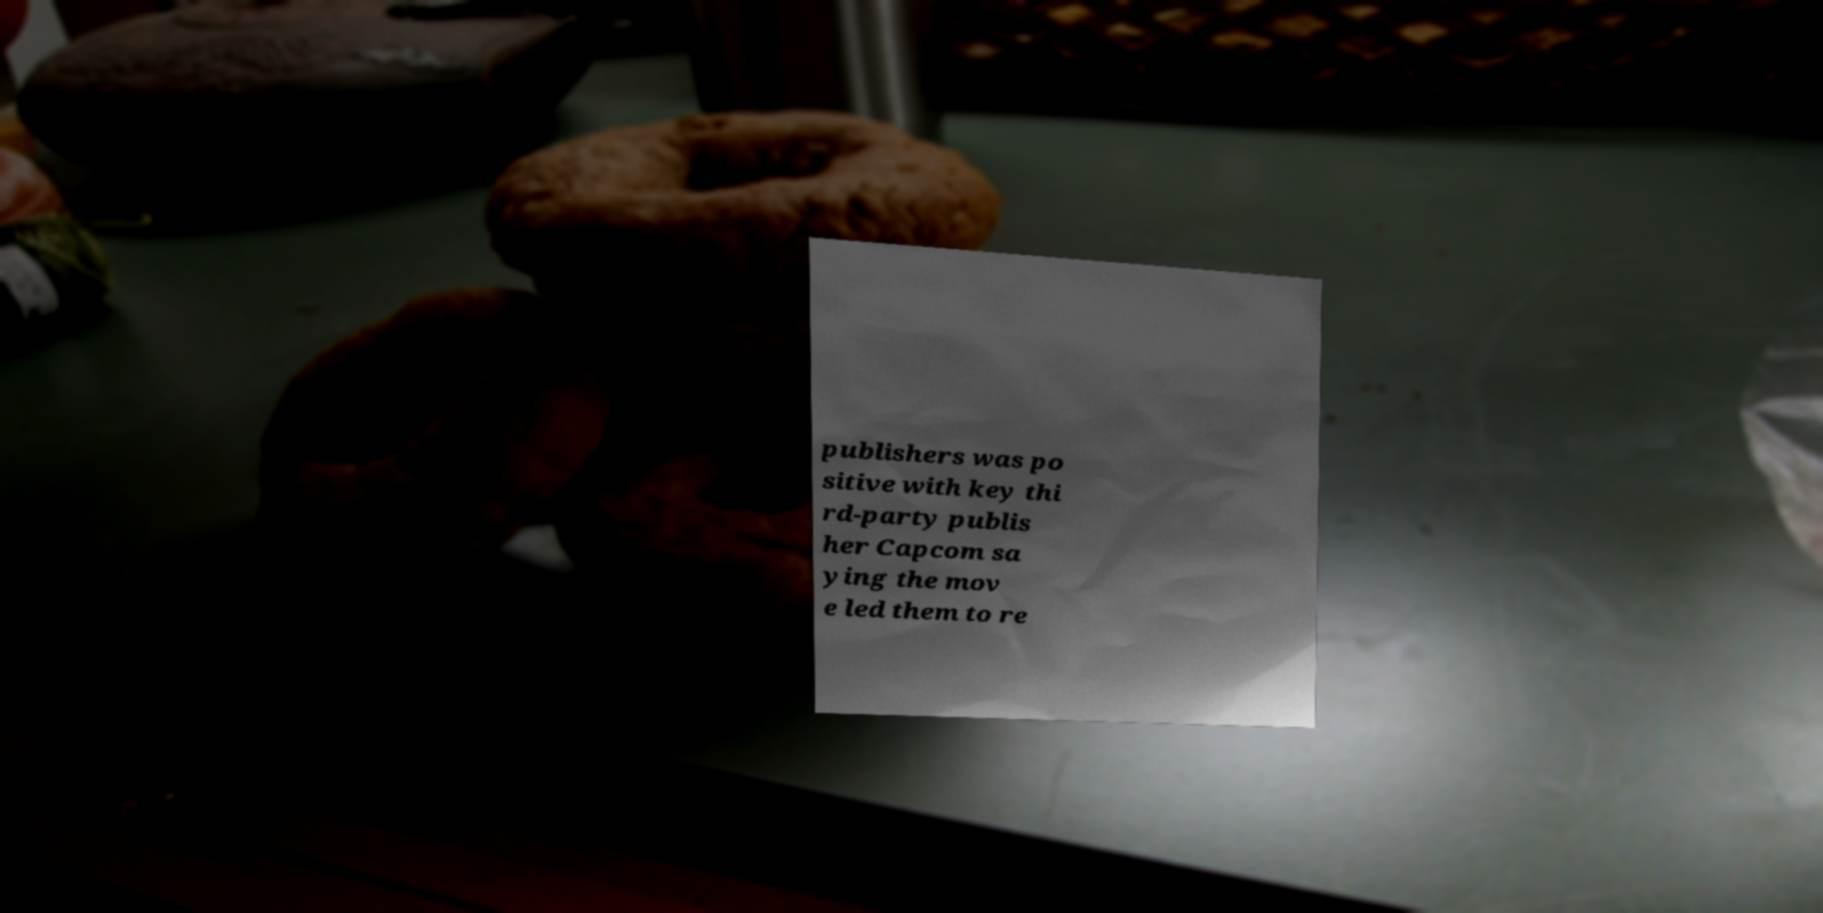Can you read and provide the text displayed in the image?This photo seems to have some interesting text. Can you extract and type it out for me? publishers was po sitive with key thi rd-party publis her Capcom sa ying the mov e led them to re 